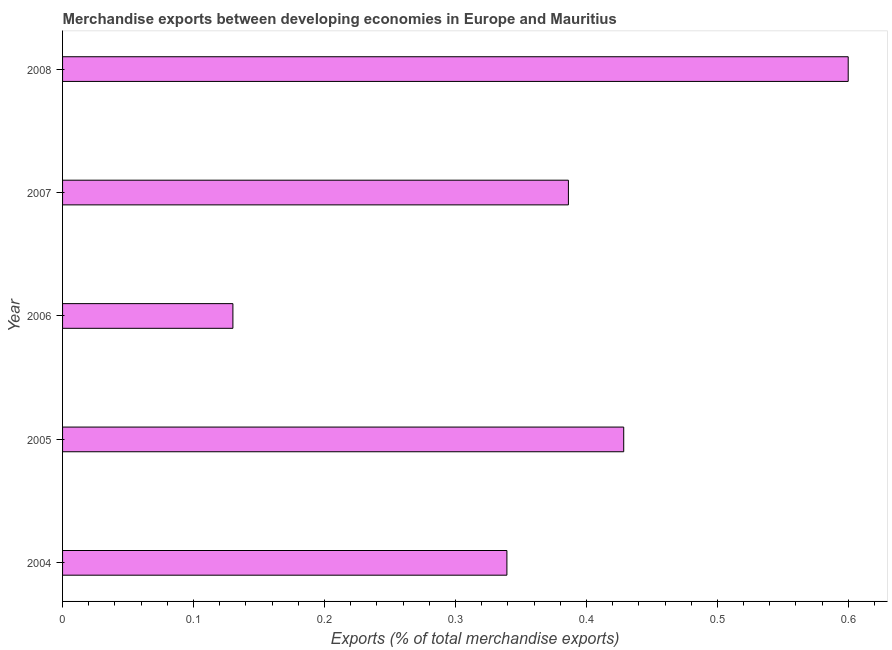Does the graph contain grids?
Make the answer very short. No. What is the title of the graph?
Ensure brevity in your answer.  Merchandise exports between developing economies in Europe and Mauritius. What is the label or title of the X-axis?
Ensure brevity in your answer.  Exports (% of total merchandise exports). What is the label or title of the Y-axis?
Give a very brief answer. Year. What is the merchandise exports in 2004?
Ensure brevity in your answer.  0.34. Across all years, what is the maximum merchandise exports?
Offer a terse response. 0.6. Across all years, what is the minimum merchandise exports?
Offer a terse response. 0.13. In which year was the merchandise exports minimum?
Make the answer very short. 2006. What is the sum of the merchandise exports?
Make the answer very short. 1.88. What is the difference between the merchandise exports in 2004 and 2008?
Your answer should be compact. -0.26. What is the average merchandise exports per year?
Your response must be concise. 0.38. What is the median merchandise exports?
Provide a short and direct response. 0.39. Do a majority of the years between 2008 and 2006 (inclusive) have merchandise exports greater than 0.32 %?
Offer a terse response. Yes. What is the ratio of the merchandise exports in 2007 to that in 2008?
Your response must be concise. 0.64. Is the merchandise exports in 2004 less than that in 2005?
Ensure brevity in your answer.  Yes. Is the difference between the merchandise exports in 2004 and 2008 greater than the difference between any two years?
Make the answer very short. No. What is the difference between the highest and the second highest merchandise exports?
Provide a succinct answer. 0.17. What is the difference between the highest and the lowest merchandise exports?
Provide a succinct answer. 0.47. In how many years, is the merchandise exports greater than the average merchandise exports taken over all years?
Offer a terse response. 3. What is the Exports (% of total merchandise exports) of 2004?
Ensure brevity in your answer.  0.34. What is the Exports (% of total merchandise exports) of 2005?
Keep it short and to the point. 0.43. What is the Exports (% of total merchandise exports) in 2006?
Give a very brief answer. 0.13. What is the Exports (% of total merchandise exports) in 2007?
Offer a very short reply. 0.39. What is the Exports (% of total merchandise exports) in 2008?
Make the answer very short. 0.6. What is the difference between the Exports (% of total merchandise exports) in 2004 and 2005?
Your response must be concise. -0.09. What is the difference between the Exports (% of total merchandise exports) in 2004 and 2006?
Offer a very short reply. 0.21. What is the difference between the Exports (% of total merchandise exports) in 2004 and 2007?
Keep it short and to the point. -0.05. What is the difference between the Exports (% of total merchandise exports) in 2004 and 2008?
Ensure brevity in your answer.  -0.26. What is the difference between the Exports (% of total merchandise exports) in 2005 and 2006?
Ensure brevity in your answer.  0.3. What is the difference between the Exports (% of total merchandise exports) in 2005 and 2007?
Your response must be concise. 0.04. What is the difference between the Exports (% of total merchandise exports) in 2005 and 2008?
Your answer should be compact. -0.17. What is the difference between the Exports (% of total merchandise exports) in 2006 and 2007?
Offer a very short reply. -0.26. What is the difference between the Exports (% of total merchandise exports) in 2006 and 2008?
Offer a very short reply. -0.47. What is the difference between the Exports (% of total merchandise exports) in 2007 and 2008?
Provide a succinct answer. -0.21. What is the ratio of the Exports (% of total merchandise exports) in 2004 to that in 2005?
Make the answer very short. 0.79. What is the ratio of the Exports (% of total merchandise exports) in 2004 to that in 2006?
Your answer should be compact. 2.61. What is the ratio of the Exports (% of total merchandise exports) in 2004 to that in 2007?
Ensure brevity in your answer.  0.88. What is the ratio of the Exports (% of total merchandise exports) in 2004 to that in 2008?
Offer a terse response. 0.57. What is the ratio of the Exports (% of total merchandise exports) in 2005 to that in 2006?
Give a very brief answer. 3.29. What is the ratio of the Exports (% of total merchandise exports) in 2005 to that in 2007?
Make the answer very short. 1.11. What is the ratio of the Exports (% of total merchandise exports) in 2005 to that in 2008?
Keep it short and to the point. 0.71. What is the ratio of the Exports (% of total merchandise exports) in 2006 to that in 2007?
Make the answer very short. 0.34. What is the ratio of the Exports (% of total merchandise exports) in 2006 to that in 2008?
Provide a short and direct response. 0.22. What is the ratio of the Exports (% of total merchandise exports) in 2007 to that in 2008?
Offer a terse response. 0.64. 